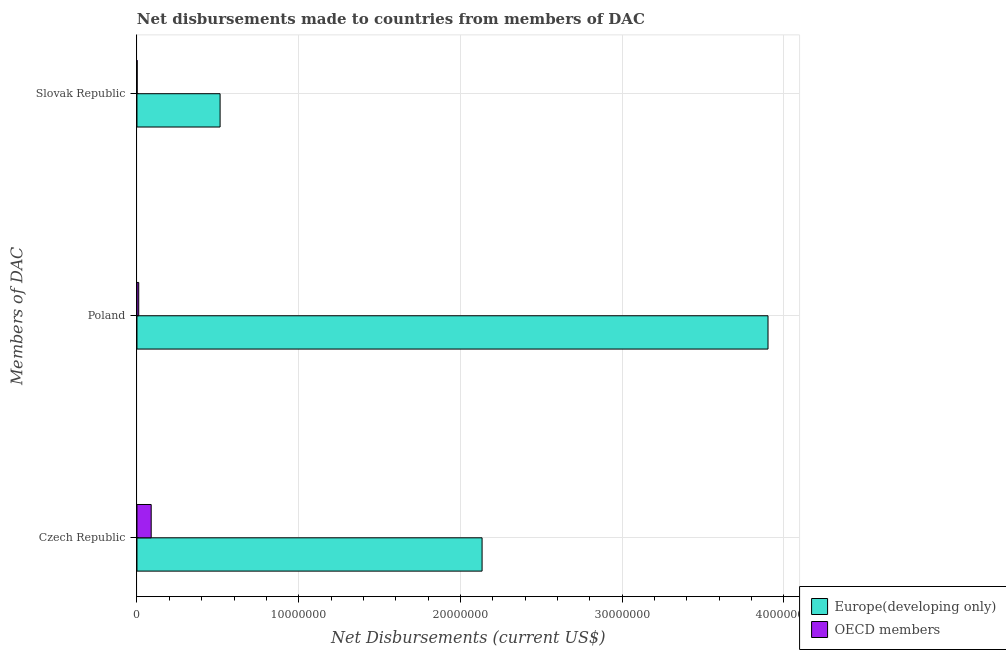Are the number of bars on each tick of the Y-axis equal?
Give a very brief answer. Yes. How many bars are there on the 1st tick from the top?
Keep it short and to the point. 2. How many bars are there on the 1st tick from the bottom?
Make the answer very short. 2. What is the label of the 3rd group of bars from the top?
Your answer should be compact. Czech Republic. What is the net disbursements made by slovak republic in OECD members?
Offer a very short reply. 10000. Across all countries, what is the maximum net disbursements made by slovak republic?
Keep it short and to the point. 5.14e+06. Across all countries, what is the minimum net disbursements made by slovak republic?
Provide a succinct answer. 10000. In which country was the net disbursements made by poland maximum?
Offer a very short reply. Europe(developing only). In which country was the net disbursements made by poland minimum?
Offer a terse response. OECD members. What is the total net disbursements made by czech republic in the graph?
Your answer should be very brief. 2.22e+07. What is the difference between the net disbursements made by poland in Europe(developing only) and that in OECD members?
Your answer should be compact. 3.89e+07. What is the difference between the net disbursements made by czech republic in OECD members and the net disbursements made by slovak republic in Europe(developing only)?
Provide a succinct answer. -4.26e+06. What is the average net disbursements made by poland per country?
Provide a short and direct response. 1.96e+07. What is the difference between the net disbursements made by slovak republic and net disbursements made by poland in Europe(developing only)?
Provide a succinct answer. -3.39e+07. What is the ratio of the net disbursements made by poland in Europe(developing only) to that in OECD members?
Offer a very short reply. 354.73. What is the difference between the highest and the second highest net disbursements made by poland?
Keep it short and to the point. 3.89e+07. What is the difference between the highest and the lowest net disbursements made by czech republic?
Your response must be concise. 2.05e+07. Is the sum of the net disbursements made by slovak republic in OECD members and Europe(developing only) greater than the maximum net disbursements made by czech republic across all countries?
Offer a very short reply. No. What does the 2nd bar from the top in Poland represents?
Keep it short and to the point. Europe(developing only). Are all the bars in the graph horizontal?
Give a very brief answer. Yes. How many countries are there in the graph?
Your answer should be very brief. 2. How many legend labels are there?
Make the answer very short. 2. What is the title of the graph?
Your response must be concise. Net disbursements made to countries from members of DAC. Does "Belize" appear as one of the legend labels in the graph?
Your answer should be compact. No. What is the label or title of the X-axis?
Your response must be concise. Net Disbursements (current US$). What is the label or title of the Y-axis?
Provide a succinct answer. Members of DAC. What is the Net Disbursements (current US$) in Europe(developing only) in Czech Republic?
Keep it short and to the point. 2.13e+07. What is the Net Disbursements (current US$) of OECD members in Czech Republic?
Your response must be concise. 8.80e+05. What is the Net Disbursements (current US$) of Europe(developing only) in Poland?
Provide a succinct answer. 3.90e+07. What is the Net Disbursements (current US$) of Europe(developing only) in Slovak Republic?
Ensure brevity in your answer.  5.14e+06. Across all Members of DAC, what is the maximum Net Disbursements (current US$) of Europe(developing only)?
Offer a very short reply. 3.90e+07. Across all Members of DAC, what is the maximum Net Disbursements (current US$) of OECD members?
Ensure brevity in your answer.  8.80e+05. Across all Members of DAC, what is the minimum Net Disbursements (current US$) of Europe(developing only)?
Make the answer very short. 5.14e+06. Across all Members of DAC, what is the minimum Net Disbursements (current US$) of OECD members?
Offer a terse response. 10000. What is the total Net Disbursements (current US$) of Europe(developing only) in the graph?
Provide a short and direct response. 6.55e+07. What is the total Net Disbursements (current US$) of OECD members in the graph?
Your answer should be compact. 1.00e+06. What is the difference between the Net Disbursements (current US$) of Europe(developing only) in Czech Republic and that in Poland?
Your answer should be compact. -1.77e+07. What is the difference between the Net Disbursements (current US$) in OECD members in Czech Republic and that in Poland?
Offer a very short reply. 7.70e+05. What is the difference between the Net Disbursements (current US$) of Europe(developing only) in Czech Republic and that in Slovak Republic?
Make the answer very short. 1.62e+07. What is the difference between the Net Disbursements (current US$) of OECD members in Czech Republic and that in Slovak Republic?
Offer a very short reply. 8.70e+05. What is the difference between the Net Disbursements (current US$) in Europe(developing only) in Poland and that in Slovak Republic?
Provide a short and direct response. 3.39e+07. What is the difference between the Net Disbursements (current US$) in Europe(developing only) in Czech Republic and the Net Disbursements (current US$) in OECD members in Poland?
Offer a terse response. 2.12e+07. What is the difference between the Net Disbursements (current US$) of Europe(developing only) in Czech Republic and the Net Disbursements (current US$) of OECD members in Slovak Republic?
Your answer should be compact. 2.13e+07. What is the difference between the Net Disbursements (current US$) of Europe(developing only) in Poland and the Net Disbursements (current US$) of OECD members in Slovak Republic?
Provide a short and direct response. 3.90e+07. What is the average Net Disbursements (current US$) in Europe(developing only) per Members of DAC?
Give a very brief answer. 2.18e+07. What is the average Net Disbursements (current US$) in OECD members per Members of DAC?
Offer a very short reply. 3.33e+05. What is the difference between the Net Disbursements (current US$) of Europe(developing only) and Net Disbursements (current US$) of OECD members in Czech Republic?
Your answer should be very brief. 2.05e+07. What is the difference between the Net Disbursements (current US$) of Europe(developing only) and Net Disbursements (current US$) of OECD members in Poland?
Make the answer very short. 3.89e+07. What is the difference between the Net Disbursements (current US$) of Europe(developing only) and Net Disbursements (current US$) of OECD members in Slovak Republic?
Provide a succinct answer. 5.13e+06. What is the ratio of the Net Disbursements (current US$) of Europe(developing only) in Czech Republic to that in Poland?
Make the answer very short. 0.55. What is the ratio of the Net Disbursements (current US$) of Europe(developing only) in Czech Republic to that in Slovak Republic?
Your answer should be compact. 4.15. What is the ratio of the Net Disbursements (current US$) of OECD members in Czech Republic to that in Slovak Republic?
Offer a very short reply. 88. What is the ratio of the Net Disbursements (current US$) of Europe(developing only) in Poland to that in Slovak Republic?
Offer a terse response. 7.59. What is the ratio of the Net Disbursements (current US$) in OECD members in Poland to that in Slovak Republic?
Give a very brief answer. 11. What is the difference between the highest and the second highest Net Disbursements (current US$) of Europe(developing only)?
Give a very brief answer. 1.77e+07. What is the difference between the highest and the second highest Net Disbursements (current US$) in OECD members?
Provide a succinct answer. 7.70e+05. What is the difference between the highest and the lowest Net Disbursements (current US$) of Europe(developing only)?
Provide a short and direct response. 3.39e+07. What is the difference between the highest and the lowest Net Disbursements (current US$) of OECD members?
Offer a very short reply. 8.70e+05. 